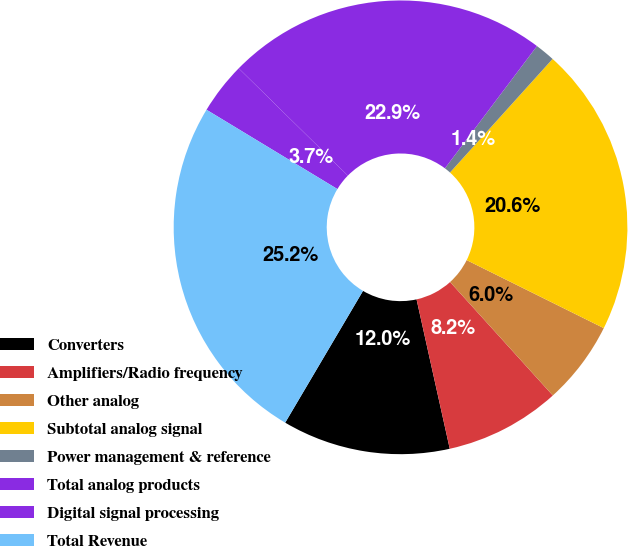Convert chart. <chart><loc_0><loc_0><loc_500><loc_500><pie_chart><fcel>Converters<fcel>Amplifiers/Radio frequency<fcel>Other analog<fcel>Subtotal analog signal<fcel>Power management & reference<fcel>Total analog products<fcel>Digital signal processing<fcel>Total Revenue<nl><fcel>11.97%<fcel>8.23%<fcel>5.96%<fcel>20.64%<fcel>1.42%<fcel>22.91%<fcel>3.69%<fcel>25.18%<nl></chart> 